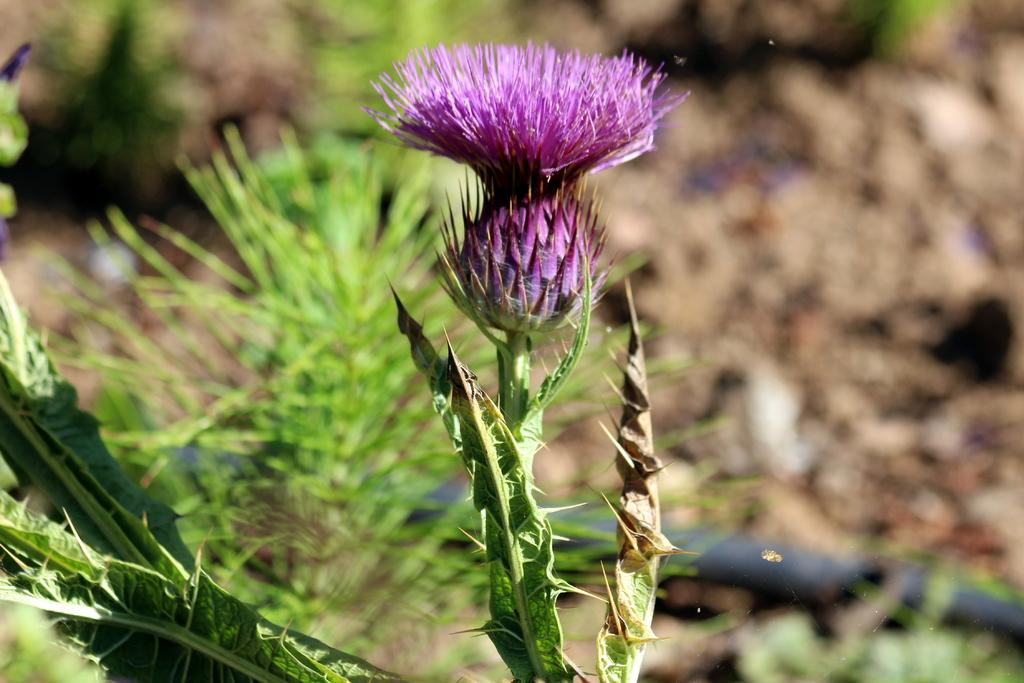What is the main subject of the image? There is a flower in the image. Can you describe the color of the flower? The flower is purple. What else can be seen in the background of the image? There are plants in the background of the image. What is the color of the plants? The plants are green. How many trees can be seen in the sea in the image? There are no trees or sea present in the image; it features a purple flower and green plants in the background. 